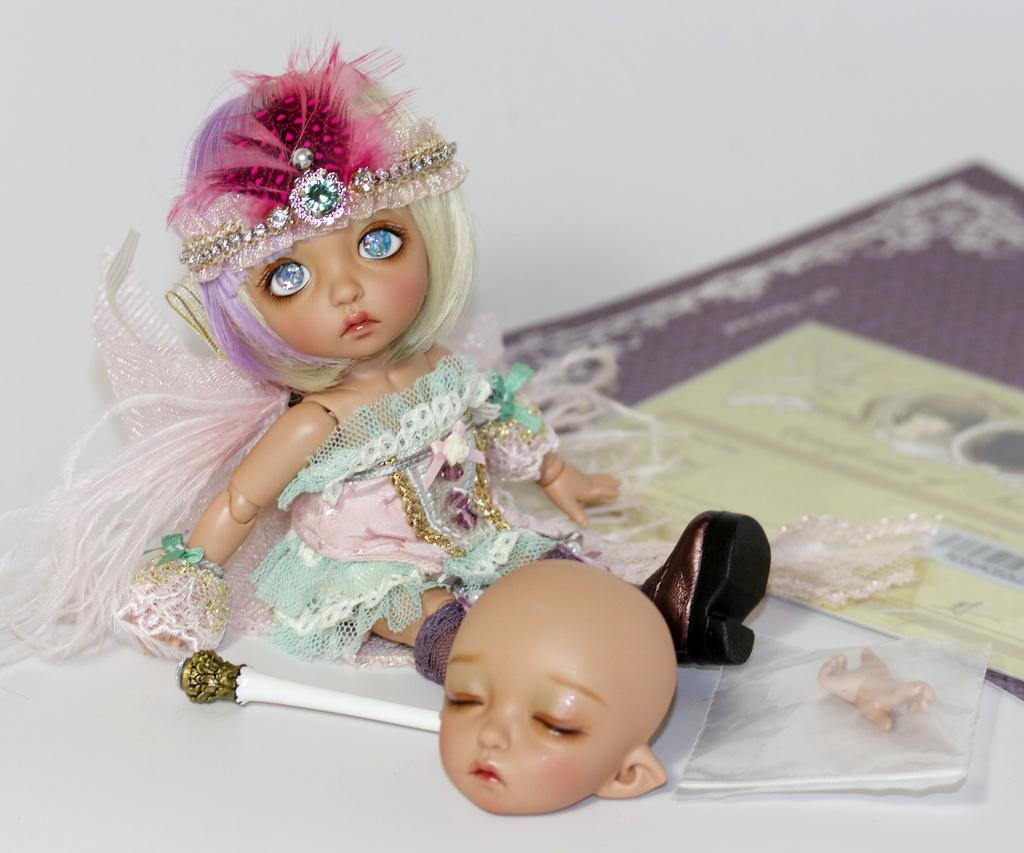What type of toys can be seen in the image? There are dolls in the image. What else is present in the image besides the dolls? There are cards and an object with doll parts packed in a transparent cover. How is the object with doll parts packaged? The object with doll parts is packaged in a transparent cover. What is the color of the remaining portion of the image? The remaining portion of the image is in white color. What type of lead is visible in the image? There is no lead present in the image. Is there a notebook in the image? There is no notebook mentioned in the provided facts, so it cannot be confirmed if one is present in the image. 